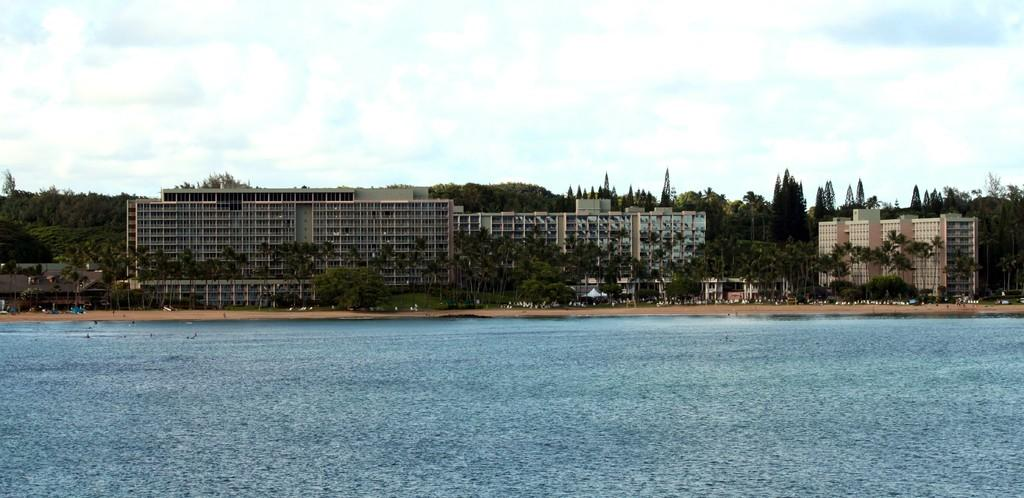What is present at the bottom of the image? There is water at the bottom side of the image. What type of natural elements can be seen in the image? There are trees in the image. What type of man-made structures are visible in the image? There are buildings in the image. What type of vehicles can be seen in the image? There are cars in the image. What type of rice is being cooked in the image? There is no rice present in the image. What type of power source is visible in the image? There is no power source visible in the image. 